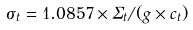<formula> <loc_0><loc_0><loc_500><loc_500>\sigma _ { t } = 1 . 0 8 5 7 \times \Sigma _ { t } / ( g \times c _ { t } )</formula> 